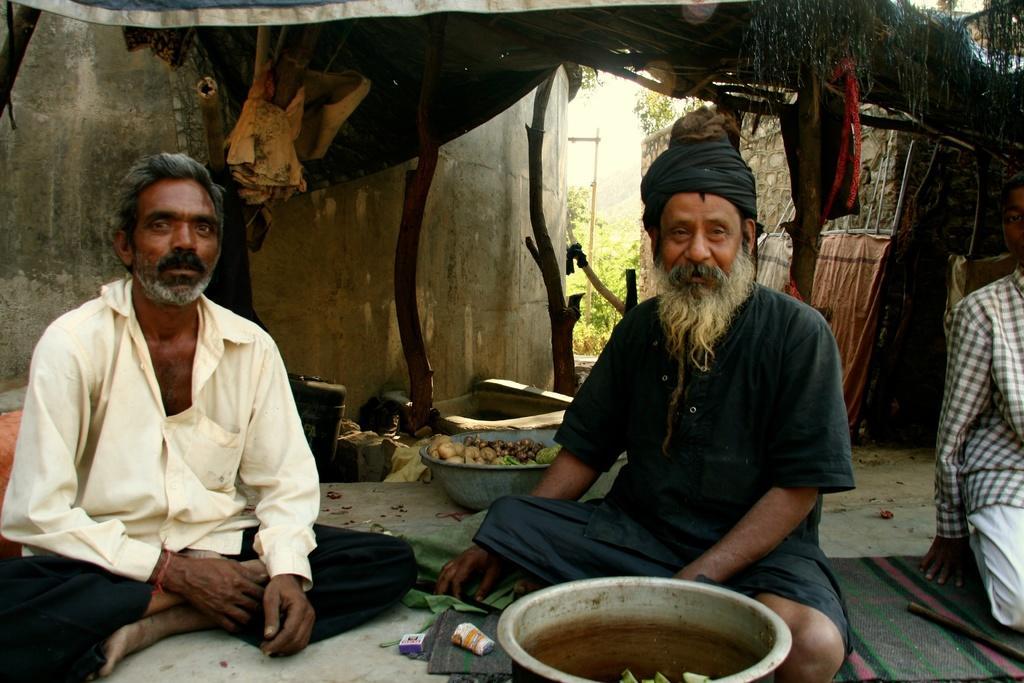How would you summarize this image in a sentence or two? In the center of the image we can see two people are sitting. In front of them, we can see some objects. On the right side of the image, we can see one blanket. On the blanket, there is an object and one person. In the background there is a wall, trees and a few other objects. 